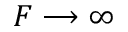Convert formula to latex. <formula><loc_0><loc_0><loc_500><loc_500>F \longrightarrow \infty</formula> 